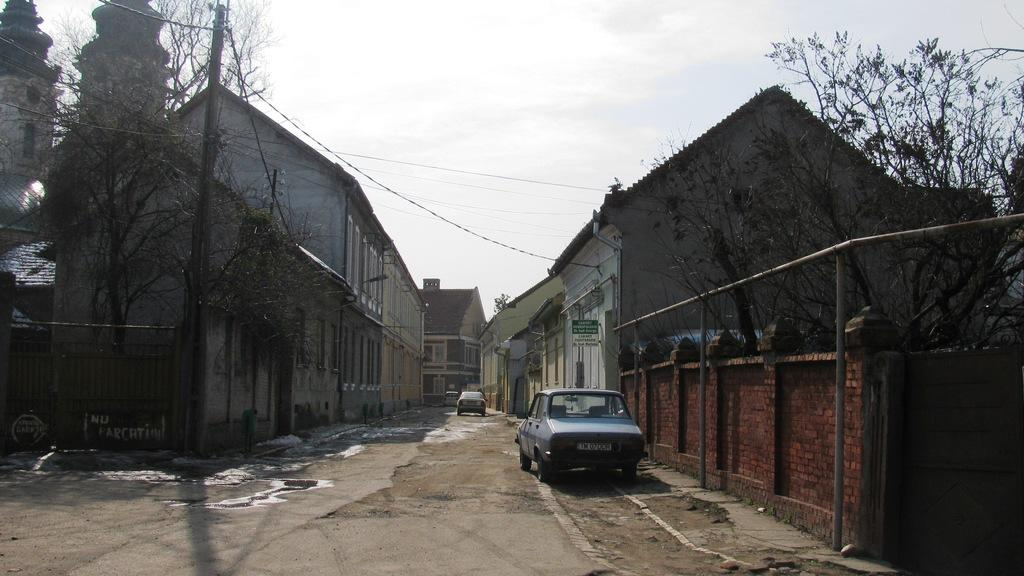How many vehicles can be seen on the road in the image? There are two vehicles on the road in the image. What can be seen in the background of the image? There are buildings and trees visible in the background. What colors are present on the buildings in the image? The buildings have cream, gray, and brown colors. What is the color of the sky in the image? The sky appears to be white in color. Where is the tray located in the image? There is no tray present in the image. What is the process for creating the colors on the buildings in the image? The process for creating the colors on the buildings is not visible or described in the image. 